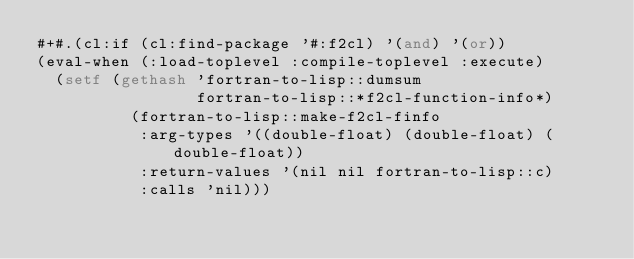Convert code to text. <code><loc_0><loc_0><loc_500><loc_500><_Lisp_>#+#.(cl:if (cl:find-package '#:f2cl) '(and) '(or))
(eval-when (:load-toplevel :compile-toplevel :execute)
  (setf (gethash 'fortran-to-lisp::dumsum
                 fortran-to-lisp::*f2cl-function-info*)
          (fortran-to-lisp::make-f2cl-finfo
           :arg-types '((double-float) (double-float) (double-float))
           :return-values '(nil nil fortran-to-lisp::c)
           :calls 'nil)))

</code> 